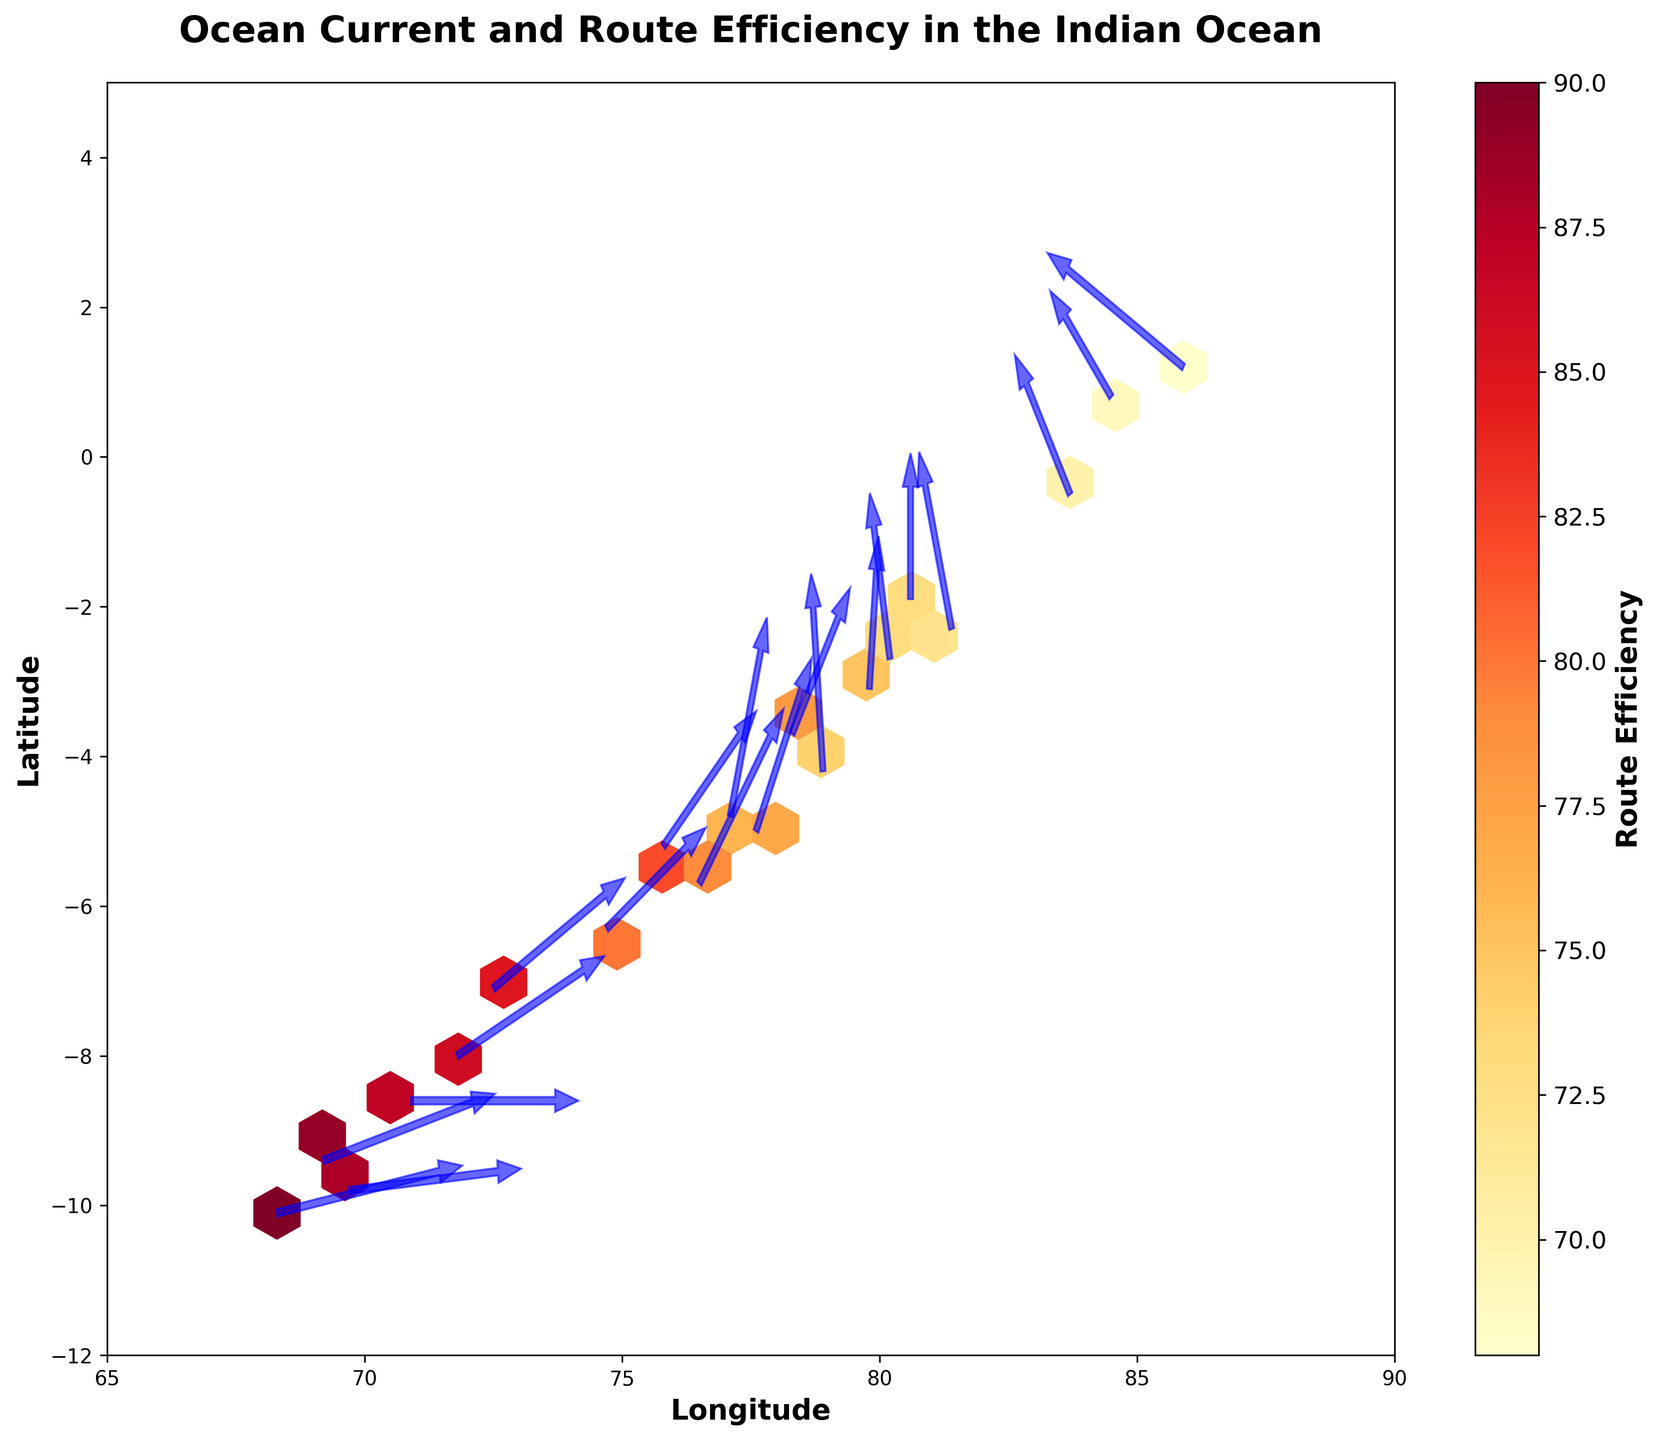What is the title of the plot? The title is located at the top of the plot and typically summarizes the main context of the figure. By reading the title, one can understand what the plot is about.
Answer: Ocean Current and Route Efficiency in the Indian Ocean What does the color bar represent? The color bar is usually positioned alongside the hexbin plot and serves as a legend for the color coding within the plot. By reading the label on the color bar, we can determine its meaning. In this case, the label indicates the metric being visualized by the colors.
Answer: Route Efficiency How are the ocean currents visualized on the plot? Ocean currents are visualized using arrows which indicate both the direction and the strength of the currents at different points on the map.
Answer: Arrows In which general area of the plot are the highest route efficiencies found? Observing the color gradient (with brighter colors indicating higher efficiencies) and the corresponding coordinates helps determine where the highest efficiencies are located.
Answer: Southwest quadrant What is the range of longitudes depicted in the plot? The x-axis represents longitude. By examining the x-axis limits, you can determine the range being shown. Here, the x-axis starts and ends at specific values.
Answer: 65 to 90 Which longitude and latitude show an ocean current strength closest to 3.0 moving in a 15-degree direction? To find this, look for the arrow that aligns with an ocean current strength of 3.0 and a direction of approximately 15 degrees. The starting point of this arrow will provide the longitude and latitude information.
Answer: Longitude 69.2, Latitude -9.4 Which quadrant of the plot has the most densely packed hexagons? Analyzing the density of hexagons, which indicates the number of data points, and identifying the quadrant with the highest density will answer this.
Answer: Southwest quadrant What color represents the lowest route efficiencies? The intensity and color gradient in the hexbin plot can indicate varying levels of the variable being measured. Identifying the colors at the lowest end of the gradient bar tells us this.
Answer: Darker/less intense colors How is the direction of ocean currents towards the northeast marked on the plot? Look for arrows pointing between the 0 and 90-degree angles (northeast) direction. Review how those directions are visualized graphically.
Answer: Arrows oriented towards the top-right What appears to be the relationship between areas with high route efficiency and the direction of ocean currents? Analyze the alignment and clusters of high route efficiency areas in relation to the direction arrows of the ocean currents to discern the relationship.
Answer: Areas with high route efficiency often align with ocean current directions 